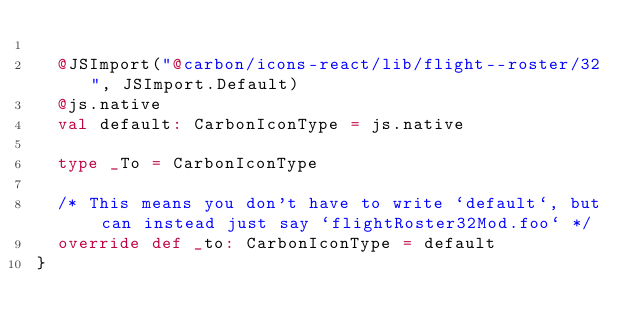Convert code to text. <code><loc_0><loc_0><loc_500><loc_500><_Scala_>  
  @JSImport("@carbon/icons-react/lib/flight--roster/32", JSImport.Default)
  @js.native
  val default: CarbonIconType = js.native
  
  type _To = CarbonIconType
  
  /* This means you don't have to write `default`, but can instead just say `flightRoster32Mod.foo` */
  override def _to: CarbonIconType = default
}
</code> 